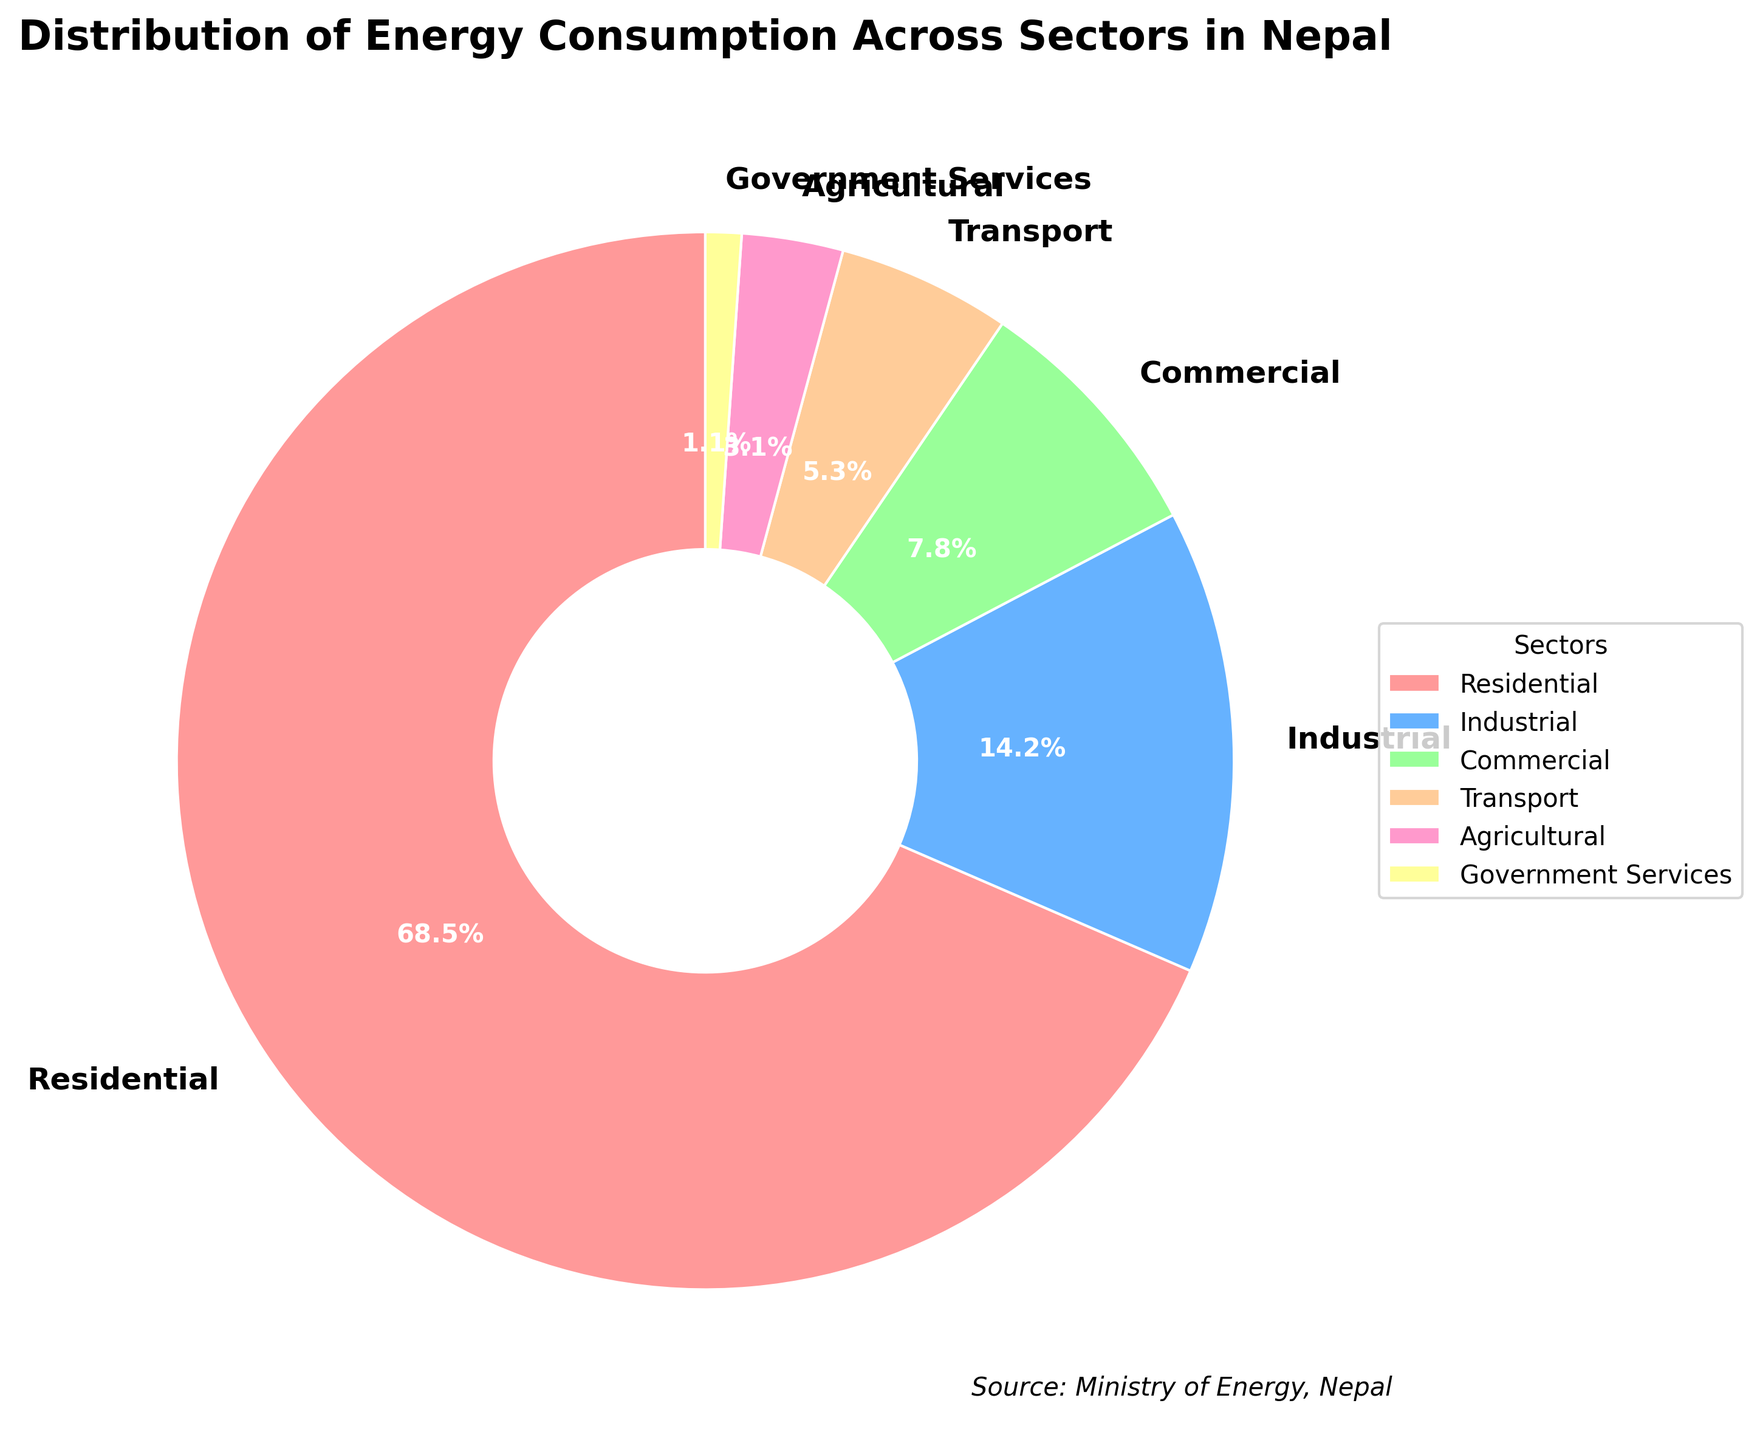How much more percentage of energy consumption does the residential sector have compared to the commercial sector? The residential sector has a consumption percentage of 68.5%, and the commercial sector has 7.8%. The difference is 68.5% - 7.8% = 60.7%.
Answer: 60.7% Which sector has the least energy consumption? By examining the pie chart, we see that the Government Services sector has the smallest portion, which is 1.1%.
Answer: Government Services Compare the energy consumption between the industrial and transport sectors. Which consumes more? The industrial sector has a consumption of 14.2%, while the transport sector has 5.3%. Therefore, the industrial sector consumes more energy compared to the transport sector.
Answer: Industrial sector What is the combined energy consumption percentage of the agricultural and government services sectors? The agricultural sector has 3.1% and the government services sector has 1.1%. Therefore, the combined percentage is 3.1% + 1.1% = 4.2%.
Answer: 4.2% What percentage of energy consumption is not attributed to the residential sector? The residential sector consumes 68.5% of the energy. Therefore, the energy not attributed to it is 100% - 68.5% = 31.5%.
Answer: 31.5% Which sector representing green color consumes energy? By examining the pie chart's legend, the sector represented by green color is the Industrial sector, consuming 14.2% of the energy.
Answer: Industrial sector Is the energy consumption of the commercial sector greater than that of the agricultural sector? The commercial sector has an energy consumption of 7.8%, while the agricultural sector has 3.1%, so the commercial sector's consumption is indeed greater.
Answer: Yes Rank the sectors from highest to lowest energy consumption. The sectors in descending order of energy consumption are: Residential (68.5%), Industrial (14.2%), Commercial (7.8%), Transport (5.3%), Agricultural (3.1%), Government Services (1.1%).
Answer: Residential, Industrial, Commercial, Transport, Agricultural, Government Services What is the difference in energy consumption percentages between the three highest-consuming sectors and the three lowest-consuming sectors? The three highest-consuming sectors are Residential (68.5%), Industrial (14.2%), and Commercial (7.8%), with a total of 68.5% + 14.2% + 7.8% = 90.5%. The three lowest-consuming sectors are Transport (5.3%), Agricultural (3.1%), and Government Services (1.1%), with a total of 5.3% + 3.1% + 1.1% = 9.5%. The difference is 90.5% - 9.5% = 81%.
Answer: 81% Which sector has a yellow color in the pie chart and what is its percentage? According to the pie chart's legend, the sector with yellow color is Government Services, which has an energy consumption of 1.1%.
Answer: Government Services, 1.1% 